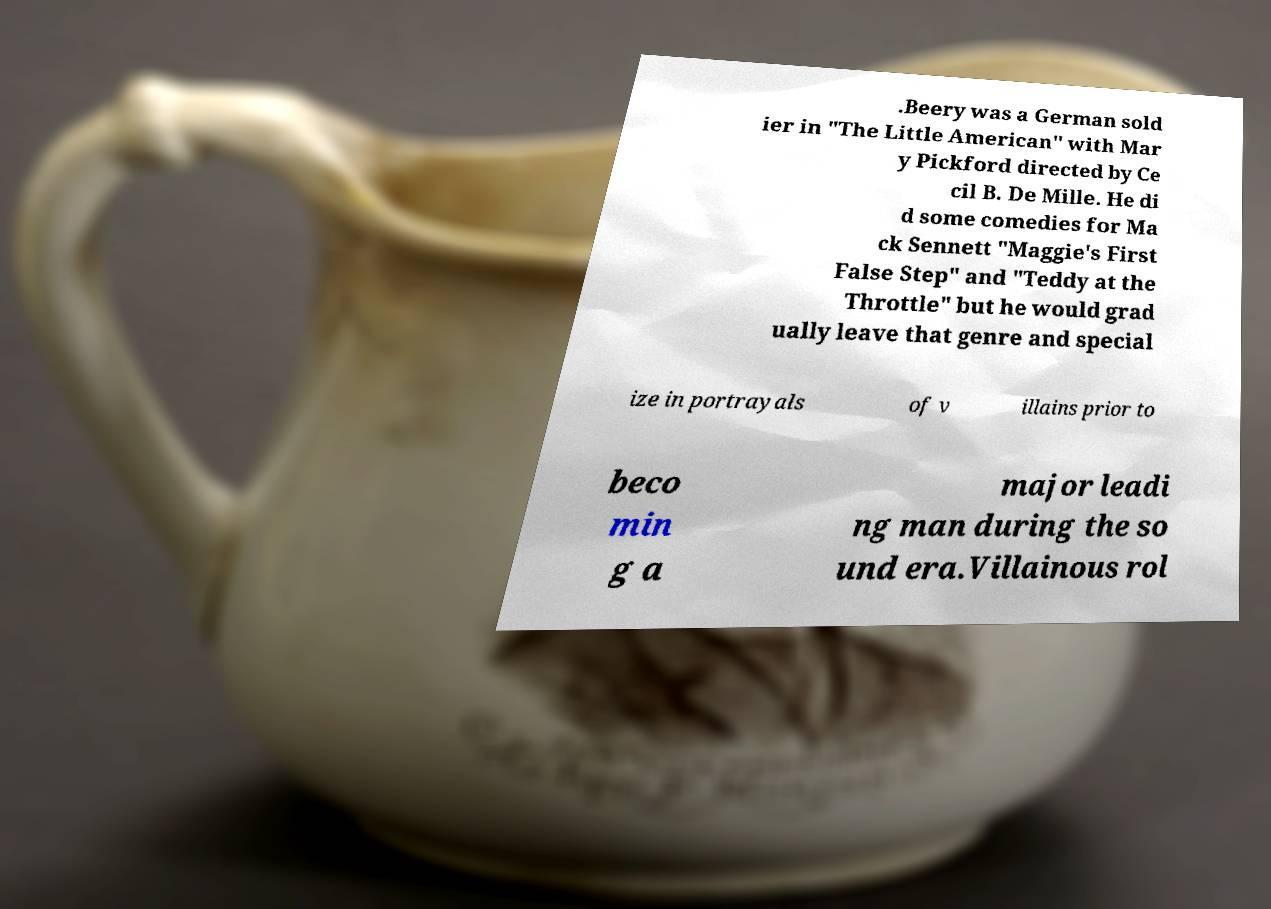For documentation purposes, I need the text within this image transcribed. Could you provide that? .Beery was a German sold ier in "The Little American" with Mar y Pickford directed by Ce cil B. De Mille. He di d some comedies for Ma ck Sennett "Maggie's First False Step" and "Teddy at the Throttle" but he would grad ually leave that genre and special ize in portrayals of v illains prior to beco min g a major leadi ng man during the so und era.Villainous rol 